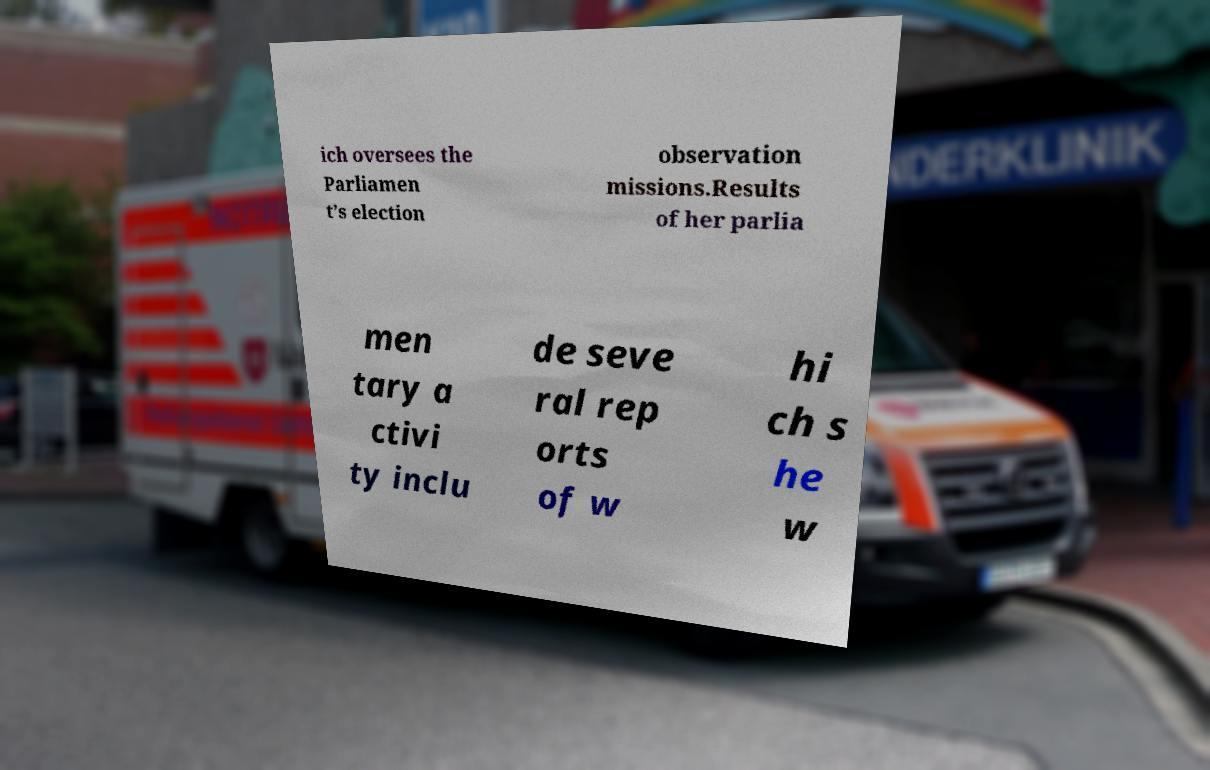Could you assist in decoding the text presented in this image and type it out clearly? ich oversees the Parliamen t’s election observation missions.Results of her parlia men tary a ctivi ty inclu de seve ral rep orts of w hi ch s he w 